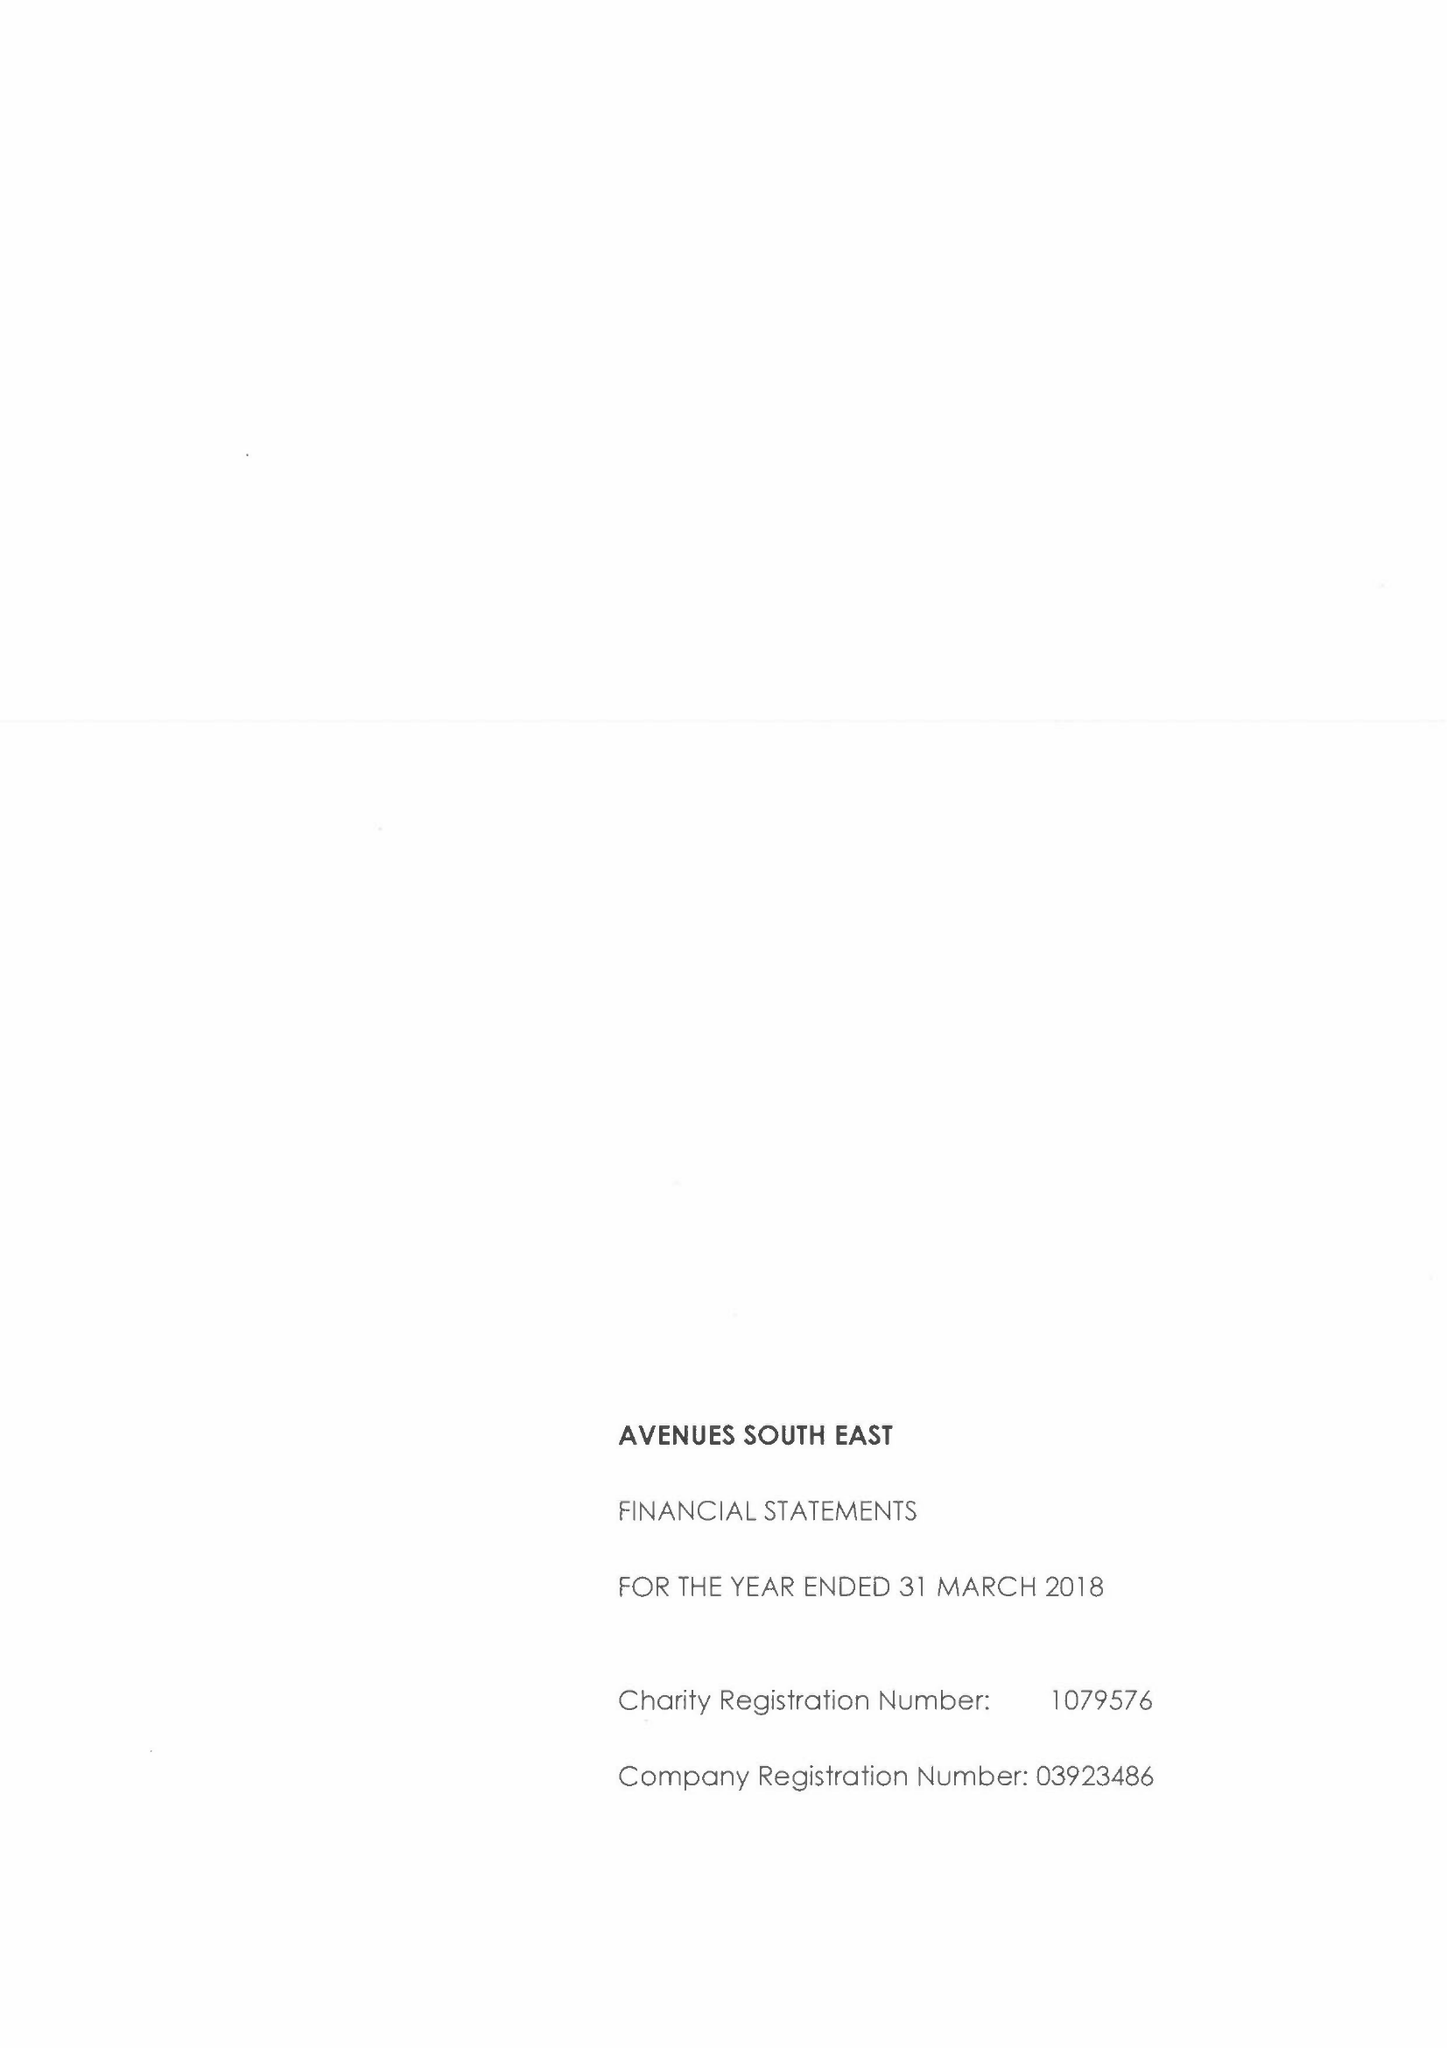What is the value for the report_date?
Answer the question using a single word or phrase. 2018-03-31 